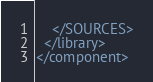<code> <loc_0><loc_0><loc_500><loc_500><_XML_>    </SOURCES>
  </library>
</component></code> 